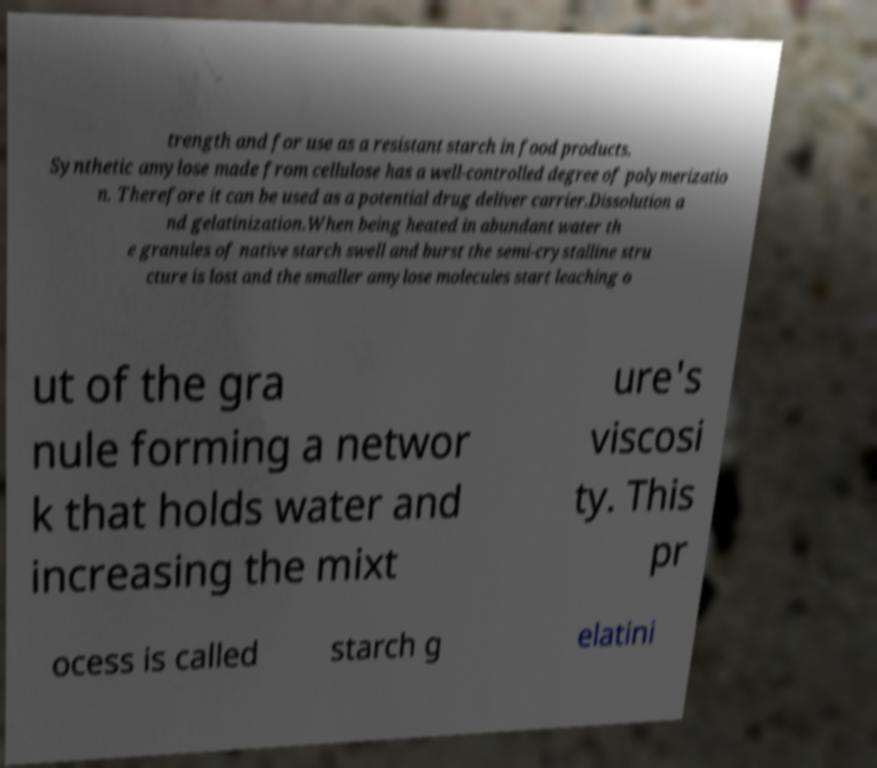Please identify and transcribe the text found in this image. trength and for use as a resistant starch in food products. Synthetic amylose made from cellulose has a well-controlled degree of polymerizatio n. Therefore it can be used as a potential drug deliver carrier.Dissolution a nd gelatinization.When being heated in abundant water th e granules of native starch swell and burst the semi-crystalline stru cture is lost and the smaller amylose molecules start leaching o ut of the gra nule forming a networ k that holds water and increasing the mixt ure's viscosi ty. This pr ocess is called starch g elatini 